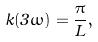<formula> <loc_0><loc_0><loc_500><loc_500>k ( 3 \omega ) = \frac { \pi } { L } ,</formula> 